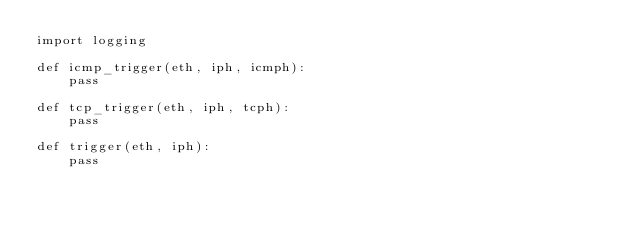<code> <loc_0><loc_0><loc_500><loc_500><_Python_>import logging

def icmp_trigger(eth, iph, icmph):
    pass

def tcp_trigger(eth, iph, tcph):
    pass

def trigger(eth, iph):
    pass</code> 